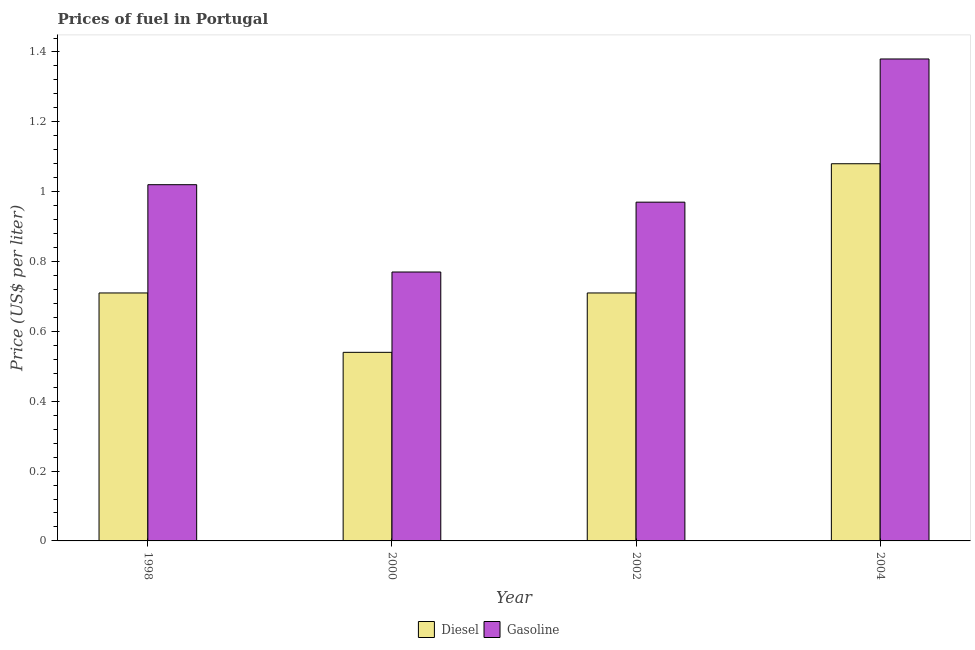How many different coloured bars are there?
Give a very brief answer. 2. Are the number of bars per tick equal to the number of legend labels?
Your response must be concise. Yes. In how many cases, is the number of bars for a given year not equal to the number of legend labels?
Offer a very short reply. 0. What is the gasoline price in 1998?
Keep it short and to the point. 1.02. Across all years, what is the minimum diesel price?
Offer a very short reply. 0.54. In which year was the gasoline price maximum?
Keep it short and to the point. 2004. What is the total diesel price in the graph?
Your answer should be compact. 3.04. What is the difference between the gasoline price in 1998 and that in 2004?
Offer a very short reply. -0.36. What is the difference between the diesel price in 2000 and the gasoline price in 2002?
Your answer should be very brief. -0.17. What is the average gasoline price per year?
Your answer should be compact. 1.03. In the year 2000, what is the difference between the diesel price and gasoline price?
Provide a short and direct response. 0. What is the ratio of the gasoline price in 1998 to that in 2004?
Ensure brevity in your answer.  0.74. Is the gasoline price in 2000 less than that in 2002?
Your answer should be compact. Yes. What is the difference between the highest and the second highest gasoline price?
Offer a terse response. 0.36. What is the difference between the highest and the lowest gasoline price?
Offer a very short reply. 0.61. In how many years, is the diesel price greater than the average diesel price taken over all years?
Provide a succinct answer. 1. Is the sum of the diesel price in 2000 and 2004 greater than the maximum gasoline price across all years?
Your answer should be very brief. Yes. What does the 1st bar from the left in 2000 represents?
Give a very brief answer. Diesel. What does the 2nd bar from the right in 2000 represents?
Give a very brief answer. Diesel. Are all the bars in the graph horizontal?
Give a very brief answer. No. Does the graph contain any zero values?
Ensure brevity in your answer.  No. Where does the legend appear in the graph?
Your answer should be compact. Bottom center. How many legend labels are there?
Keep it short and to the point. 2. How are the legend labels stacked?
Your answer should be compact. Horizontal. What is the title of the graph?
Offer a very short reply. Prices of fuel in Portugal. Does "National Visitors" appear as one of the legend labels in the graph?
Your response must be concise. No. What is the label or title of the X-axis?
Your answer should be very brief. Year. What is the label or title of the Y-axis?
Provide a succinct answer. Price (US$ per liter). What is the Price (US$ per liter) in Diesel in 1998?
Give a very brief answer. 0.71. What is the Price (US$ per liter) of Diesel in 2000?
Ensure brevity in your answer.  0.54. What is the Price (US$ per liter) in Gasoline in 2000?
Ensure brevity in your answer.  0.77. What is the Price (US$ per liter) in Diesel in 2002?
Keep it short and to the point. 0.71. What is the Price (US$ per liter) of Gasoline in 2004?
Your answer should be very brief. 1.38. Across all years, what is the maximum Price (US$ per liter) in Gasoline?
Ensure brevity in your answer.  1.38. Across all years, what is the minimum Price (US$ per liter) of Diesel?
Make the answer very short. 0.54. Across all years, what is the minimum Price (US$ per liter) of Gasoline?
Your answer should be very brief. 0.77. What is the total Price (US$ per liter) of Diesel in the graph?
Provide a succinct answer. 3.04. What is the total Price (US$ per liter) of Gasoline in the graph?
Offer a very short reply. 4.14. What is the difference between the Price (US$ per liter) in Diesel in 1998 and that in 2000?
Ensure brevity in your answer.  0.17. What is the difference between the Price (US$ per liter) in Diesel in 1998 and that in 2004?
Offer a terse response. -0.37. What is the difference between the Price (US$ per liter) of Gasoline in 1998 and that in 2004?
Ensure brevity in your answer.  -0.36. What is the difference between the Price (US$ per liter) in Diesel in 2000 and that in 2002?
Give a very brief answer. -0.17. What is the difference between the Price (US$ per liter) in Gasoline in 2000 and that in 2002?
Provide a short and direct response. -0.2. What is the difference between the Price (US$ per liter) in Diesel in 2000 and that in 2004?
Your response must be concise. -0.54. What is the difference between the Price (US$ per liter) in Gasoline in 2000 and that in 2004?
Provide a short and direct response. -0.61. What is the difference between the Price (US$ per liter) in Diesel in 2002 and that in 2004?
Provide a succinct answer. -0.37. What is the difference between the Price (US$ per liter) in Gasoline in 2002 and that in 2004?
Offer a terse response. -0.41. What is the difference between the Price (US$ per liter) of Diesel in 1998 and the Price (US$ per liter) of Gasoline in 2000?
Keep it short and to the point. -0.06. What is the difference between the Price (US$ per liter) of Diesel in 1998 and the Price (US$ per liter) of Gasoline in 2002?
Ensure brevity in your answer.  -0.26. What is the difference between the Price (US$ per liter) of Diesel in 1998 and the Price (US$ per liter) of Gasoline in 2004?
Ensure brevity in your answer.  -0.67. What is the difference between the Price (US$ per liter) of Diesel in 2000 and the Price (US$ per liter) of Gasoline in 2002?
Offer a very short reply. -0.43. What is the difference between the Price (US$ per liter) in Diesel in 2000 and the Price (US$ per liter) in Gasoline in 2004?
Offer a very short reply. -0.84. What is the difference between the Price (US$ per liter) of Diesel in 2002 and the Price (US$ per liter) of Gasoline in 2004?
Your answer should be very brief. -0.67. What is the average Price (US$ per liter) in Diesel per year?
Provide a succinct answer. 0.76. What is the average Price (US$ per liter) in Gasoline per year?
Offer a terse response. 1.03. In the year 1998, what is the difference between the Price (US$ per liter) of Diesel and Price (US$ per liter) of Gasoline?
Offer a very short reply. -0.31. In the year 2000, what is the difference between the Price (US$ per liter) in Diesel and Price (US$ per liter) in Gasoline?
Your response must be concise. -0.23. In the year 2002, what is the difference between the Price (US$ per liter) of Diesel and Price (US$ per liter) of Gasoline?
Offer a very short reply. -0.26. In the year 2004, what is the difference between the Price (US$ per liter) in Diesel and Price (US$ per liter) in Gasoline?
Your response must be concise. -0.3. What is the ratio of the Price (US$ per liter) of Diesel in 1998 to that in 2000?
Make the answer very short. 1.31. What is the ratio of the Price (US$ per liter) in Gasoline in 1998 to that in 2000?
Your answer should be very brief. 1.32. What is the ratio of the Price (US$ per liter) in Gasoline in 1998 to that in 2002?
Keep it short and to the point. 1.05. What is the ratio of the Price (US$ per liter) of Diesel in 1998 to that in 2004?
Your answer should be very brief. 0.66. What is the ratio of the Price (US$ per liter) of Gasoline in 1998 to that in 2004?
Your answer should be compact. 0.74. What is the ratio of the Price (US$ per liter) of Diesel in 2000 to that in 2002?
Give a very brief answer. 0.76. What is the ratio of the Price (US$ per liter) of Gasoline in 2000 to that in 2002?
Your response must be concise. 0.79. What is the ratio of the Price (US$ per liter) of Gasoline in 2000 to that in 2004?
Make the answer very short. 0.56. What is the ratio of the Price (US$ per liter) in Diesel in 2002 to that in 2004?
Keep it short and to the point. 0.66. What is the ratio of the Price (US$ per liter) in Gasoline in 2002 to that in 2004?
Provide a short and direct response. 0.7. What is the difference between the highest and the second highest Price (US$ per liter) of Diesel?
Provide a short and direct response. 0.37. What is the difference between the highest and the second highest Price (US$ per liter) of Gasoline?
Keep it short and to the point. 0.36. What is the difference between the highest and the lowest Price (US$ per liter) of Diesel?
Provide a short and direct response. 0.54. What is the difference between the highest and the lowest Price (US$ per liter) in Gasoline?
Offer a terse response. 0.61. 